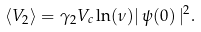<formula> <loc_0><loc_0><loc_500><loc_500>\langle V _ { 2 } \rangle = \gamma _ { 2 } V _ { c } \ln ( \nu ) | \, \psi ( 0 ) \, | ^ { 2 } .</formula> 